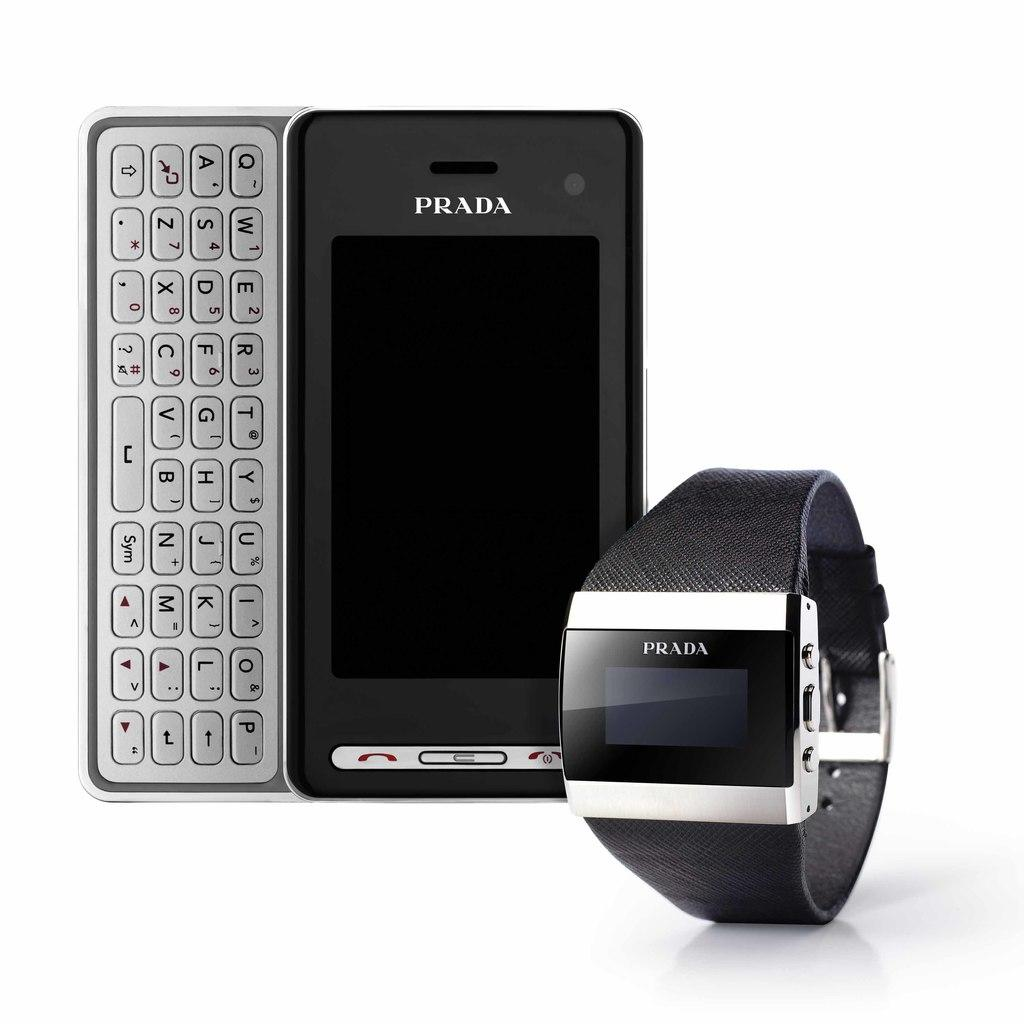<image>
Write a terse but informative summary of the picture. Mobile phone and watch made by Prada on display 